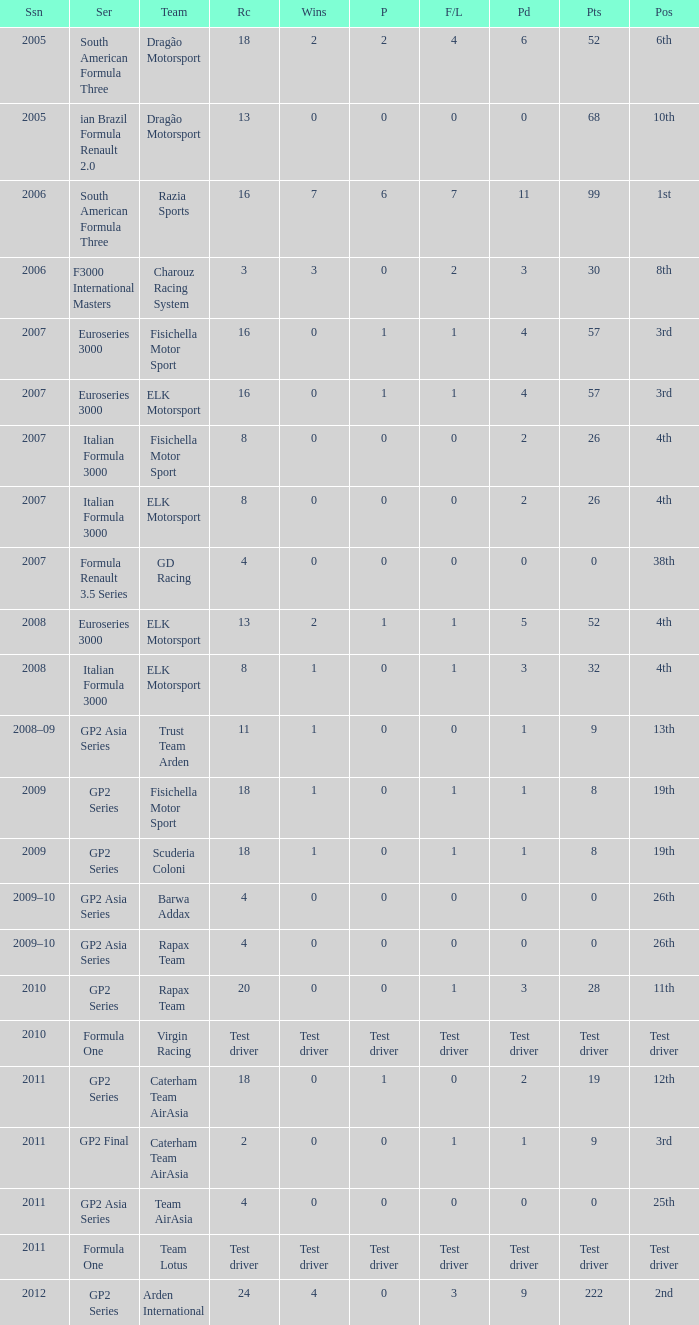In which season did he have 0 Poles and 19th position in the GP2 Series? 2009, 2009. 